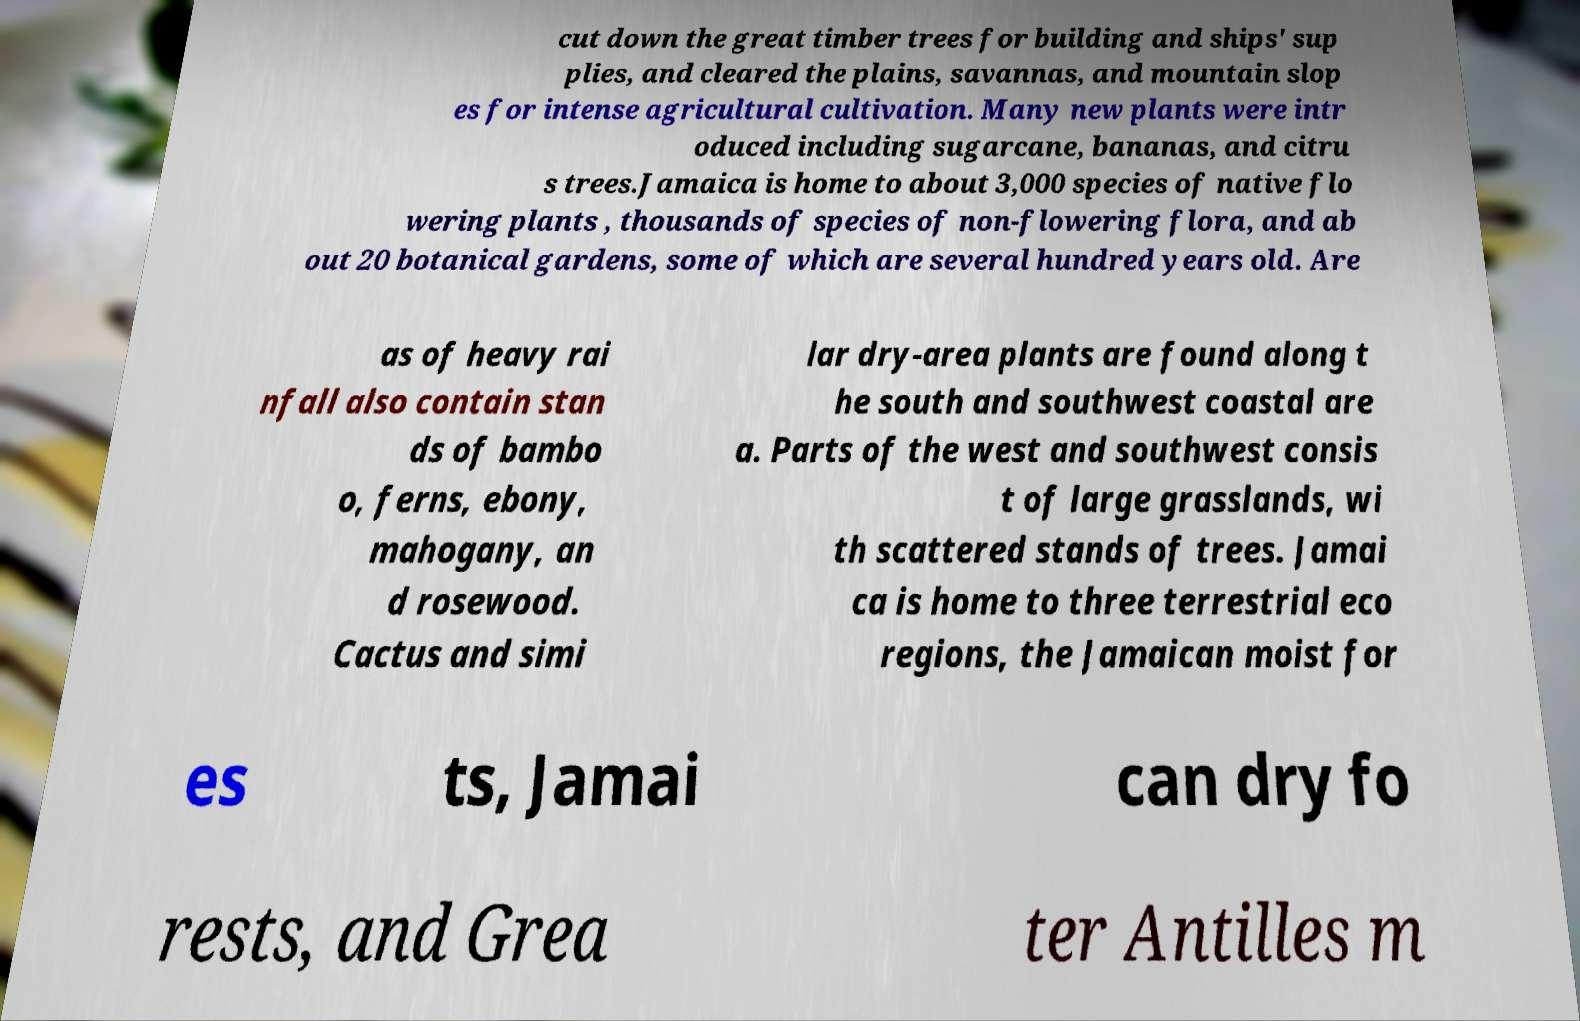Please identify and transcribe the text found in this image. cut down the great timber trees for building and ships' sup plies, and cleared the plains, savannas, and mountain slop es for intense agricultural cultivation. Many new plants were intr oduced including sugarcane, bananas, and citru s trees.Jamaica is home to about 3,000 species of native flo wering plants , thousands of species of non-flowering flora, and ab out 20 botanical gardens, some of which are several hundred years old. Are as of heavy rai nfall also contain stan ds of bambo o, ferns, ebony, mahogany, an d rosewood. Cactus and simi lar dry-area plants are found along t he south and southwest coastal are a. Parts of the west and southwest consis t of large grasslands, wi th scattered stands of trees. Jamai ca is home to three terrestrial eco regions, the Jamaican moist for es ts, Jamai can dry fo rests, and Grea ter Antilles m 